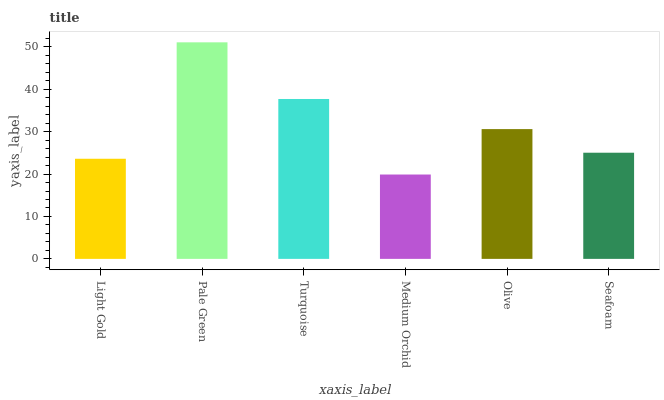Is Medium Orchid the minimum?
Answer yes or no. Yes. Is Pale Green the maximum?
Answer yes or no. Yes. Is Turquoise the minimum?
Answer yes or no. No. Is Turquoise the maximum?
Answer yes or no. No. Is Pale Green greater than Turquoise?
Answer yes or no. Yes. Is Turquoise less than Pale Green?
Answer yes or no. Yes. Is Turquoise greater than Pale Green?
Answer yes or no. No. Is Pale Green less than Turquoise?
Answer yes or no. No. Is Olive the high median?
Answer yes or no. Yes. Is Seafoam the low median?
Answer yes or no. Yes. Is Pale Green the high median?
Answer yes or no. No. Is Turquoise the low median?
Answer yes or no. No. 